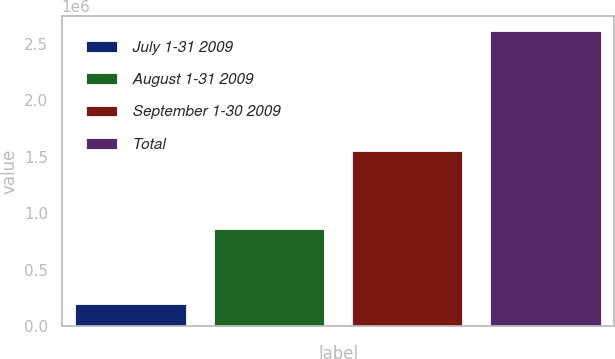<chart> <loc_0><loc_0><loc_500><loc_500><bar_chart><fcel>July 1-31 2009<fcel>August 1-31 2009<fcel>September 1-30 2009<fcel>Total<nl><fcel>200000<fcel>862500<fcel>1.549e+06<fcel>2.6115e+06<nl></chart> 